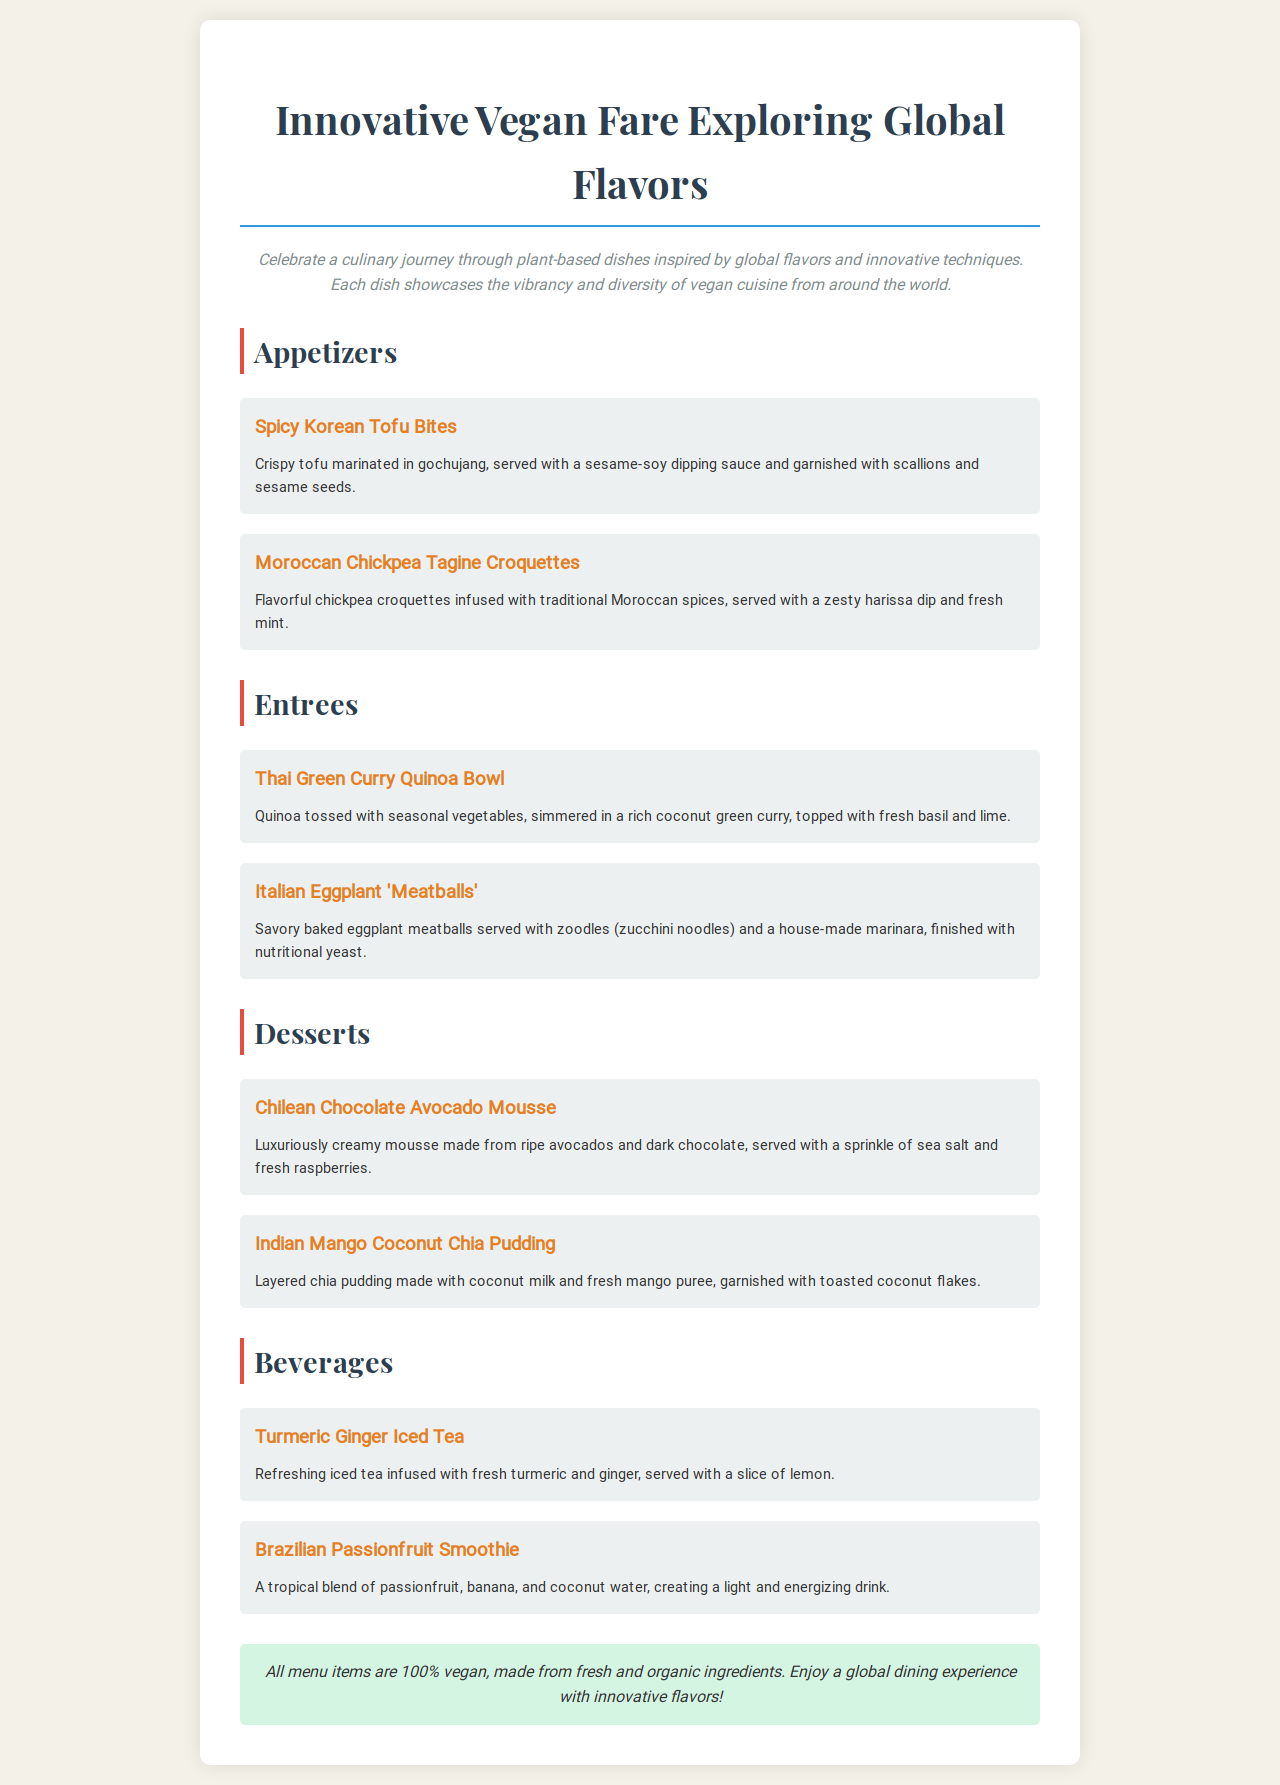What is the title of the menu? The title of the menu is prominently displayed as "Innovative Vegan Fare Exploring Global Flavors."
Answer: Innovative Vegan Fare Exploring Global Flavors How many appetizers are listed in the menu? There are two appetizers listed in the menu under the section "Appetizers."
Answer: 2 Which dish features avocado? The dessert that features avocado is specifically the "Chilean Chocolate Avocado Mousse."
Answer: Chilean Chocolate Avocado Mousse What type of noodles are used in the Italian dish? The Italian Eggplant 'Meatballs' are served with "zoodles," which are zucchini noodles.
Answer: Zoodles What vegetable is included in the Thai Green Curry dish? The Thai Green Curry Quinoa Bowl includes "seasonal vegetables."
Answer: Seasonal vegetables What type of pudding is featured in the desserts? The dessert item included is "Indian Mango Coconut Chia Pudding."
Answer: Indian Mango Coconut Chia Pudding What kind of tea is offered as a beverage? One of the beverages on the menu is "Turmeric Ginger Iced Tea."
Answer: Turmeric Ginger Iced Tea How are the Moroccan biscuits served? The Moroccan Chickpea Tagine Croquettes are served with a "zesty harissa dip."
Answer: Zesty harissa dip What key attribute is highlighted for all menu items? All menu items are highlighted as being "100% vegan."
Answer: 100% vegan 